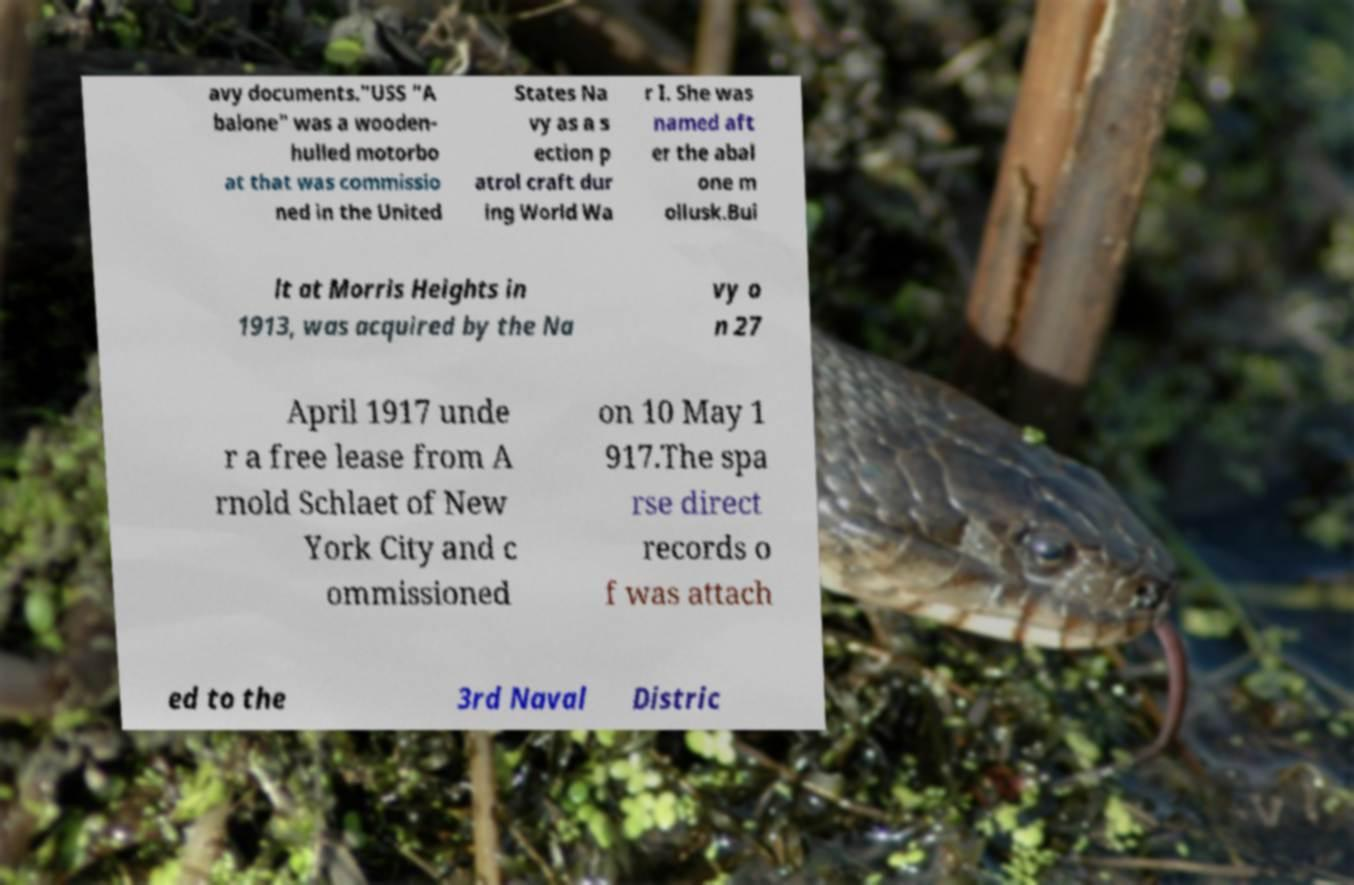I need the written content from this picture converted into text. Can you do that? avy documents."USS "A balone" was a wooden- hulled motorbo at that was commissio ned in the United States Na vy as a s ection p atrol craft dur ing World Wa r I. She was named aft er the abal one m ollusk.Bui lt at Morris Heights in 1913, was acquired by the Na vy o n 27 April 1917 unde r a free lease from A rnold Schlaet of New York City and c ommissioned on 10 May 1 917.The spa rse direct records o f was attach ed to the 3rd Naval Distric 